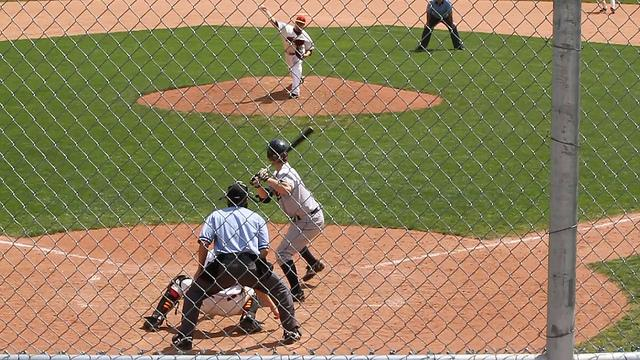The fence is placed in front of what part of the stadium to stop the pitchers fastball from hitting it? home plate 